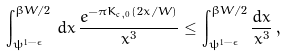Convert formula to latex. <formula><loc_0><loc_0><loc_500><loc_500>\int _ { \psi ^ { 1 - \epsilon } } ^ { \beta W / 2 } \, d x \, \frac { e ^ { - \pi K _ { \text {c} , 0 } ( 2 x / W ) } } { x ^ { 3 } } \leq \int _ { \psi ^ { 1 - \epsilon } } ^ { \beta W / 2 } \frac { d x } { x ^ { 3 } } \, ,</formula> 